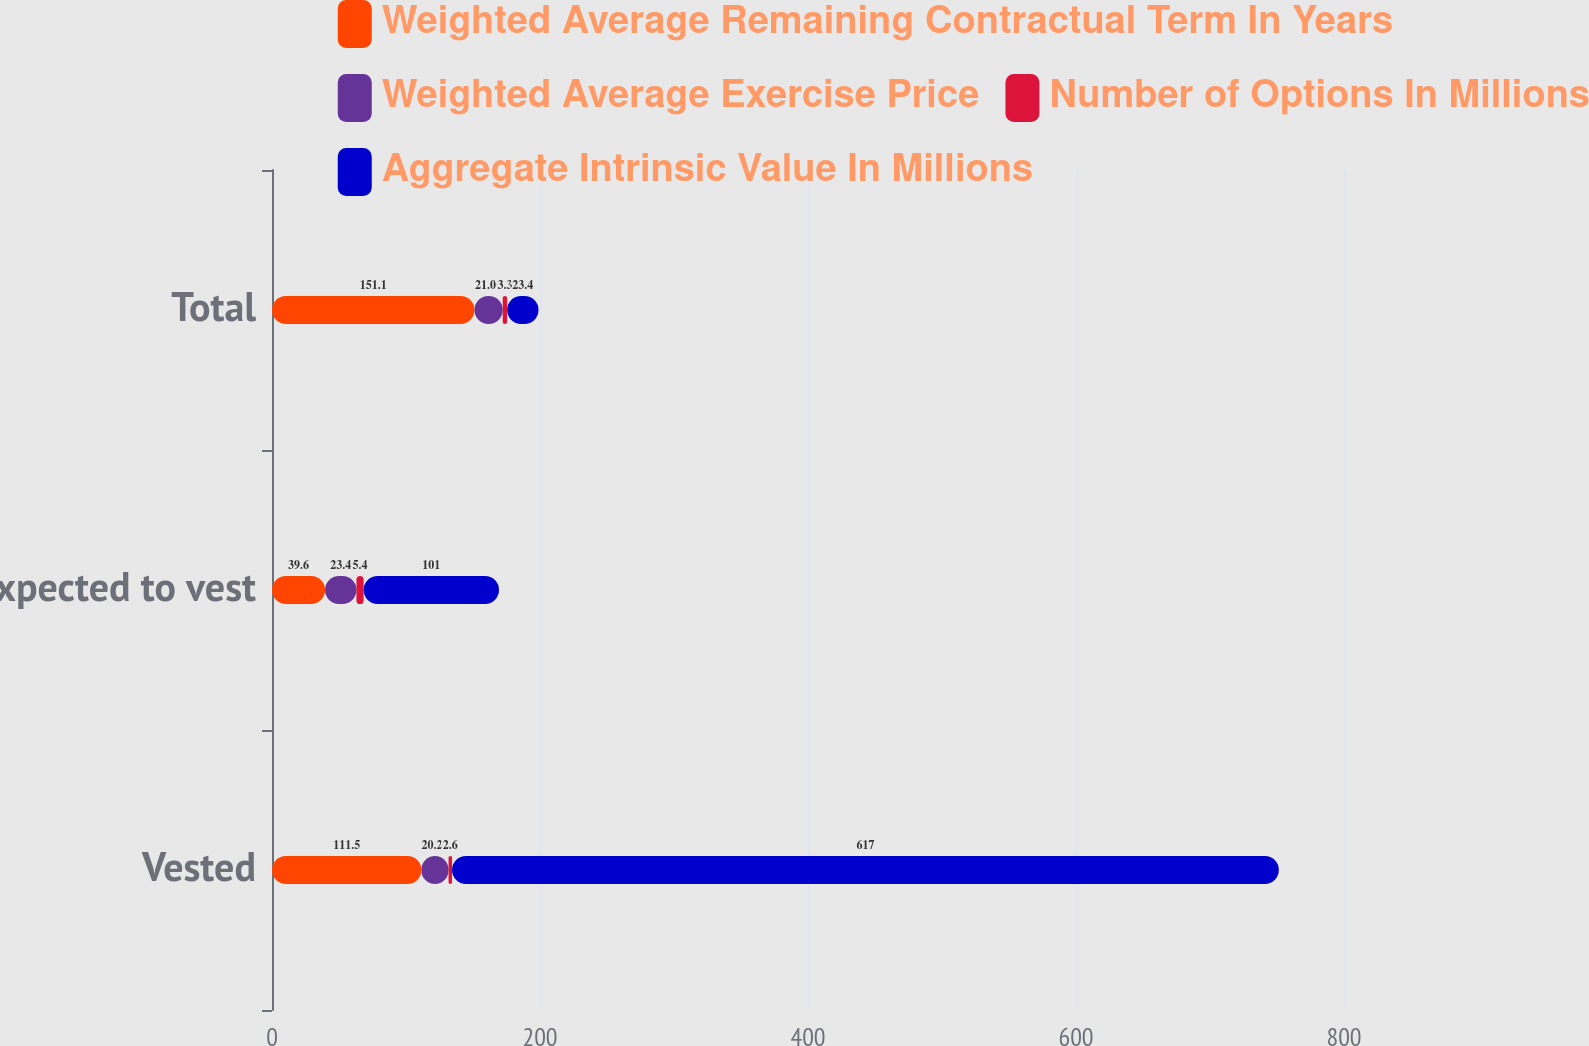<chart> <loc_0><loc_0><loc_500><loc_500><stacked_bar_chart><ecel><fcel>Vested<fcel>Expected to vest<fcel>Total<nl><fcel>Weighted Average Remaining Contractual Term In Years<fcel>111.5<fcel>39.6<fcel>151.1<nl><fcel>Weighted Average Exercise Price<fcel>20.25<fcel>23.4<fcel>21.08<nl><fcel>Number of Options In Millions<fcel>2.6<fcel>5.4<fcel>3.3<nl><fcel>Aggregate Intrinsic Value In Millions<fcel>617<fcel>101<fcel>23.4<nl></chart> 